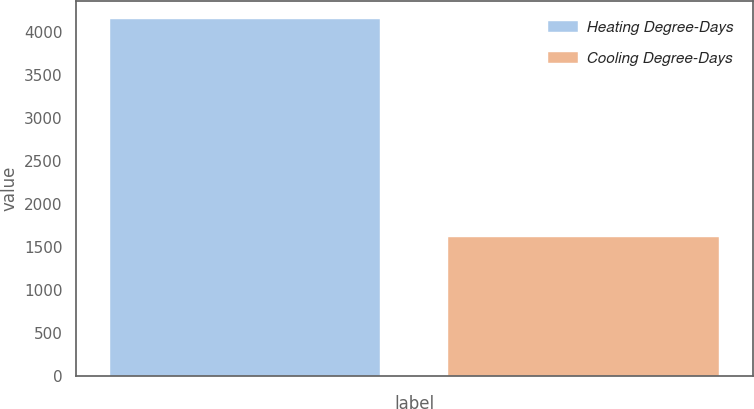<chart> <loc_0><loc_0><loc_500><loc_500><bar_chart><fcel>Heating Degree-Days<fcel>Cooling Degree-Days<nl><fcel>4157<fcel>1617<nl></chart> 